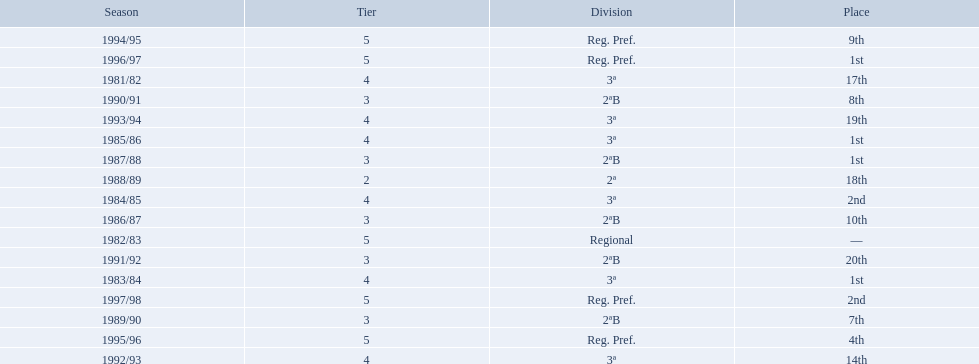In what years did the team finish 17th or worse? 1981/82, 1988/89, 1991/92, 1993/94. Of those, in which year the team finish worse? 1991/92. 